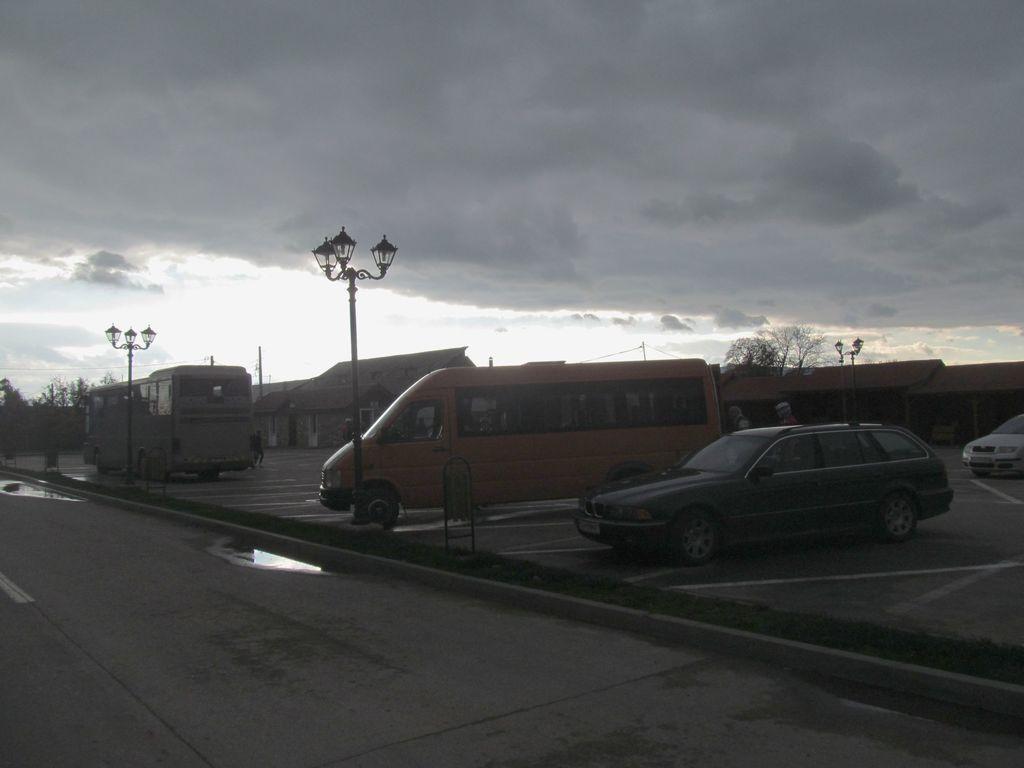In one or two sentences, can you explain what this image depicts? In this image I can see the road, some water on the road, few vehicles and few street light poles. In the background I can see few buildings, few poles, few trees and the sky. 